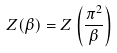<formula> <loc_0><loc_0><loc_500><loc_500>Z ( \beta ) = Z \left ( \frac { \pi ^ { 2 } } { \beta } \right )</formula> 